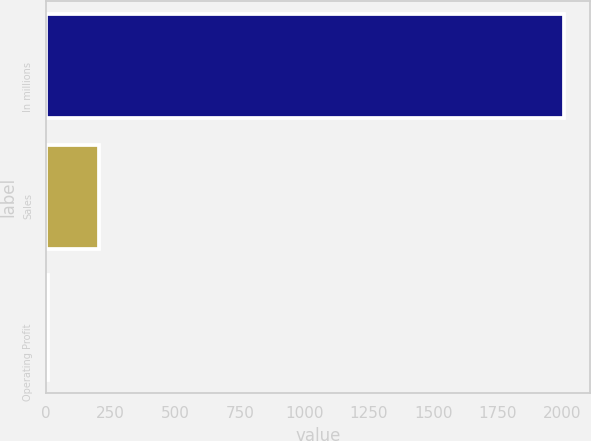Convert chart to OTSL. <chart><loc_0><loc_0><loc_500><loc_500><bar_chart><fcel>In millions<fcel>Sales<fcel>Operating Profit<nl><fcel>2007<fcel>206.1<fcel>6<nl></chart> 